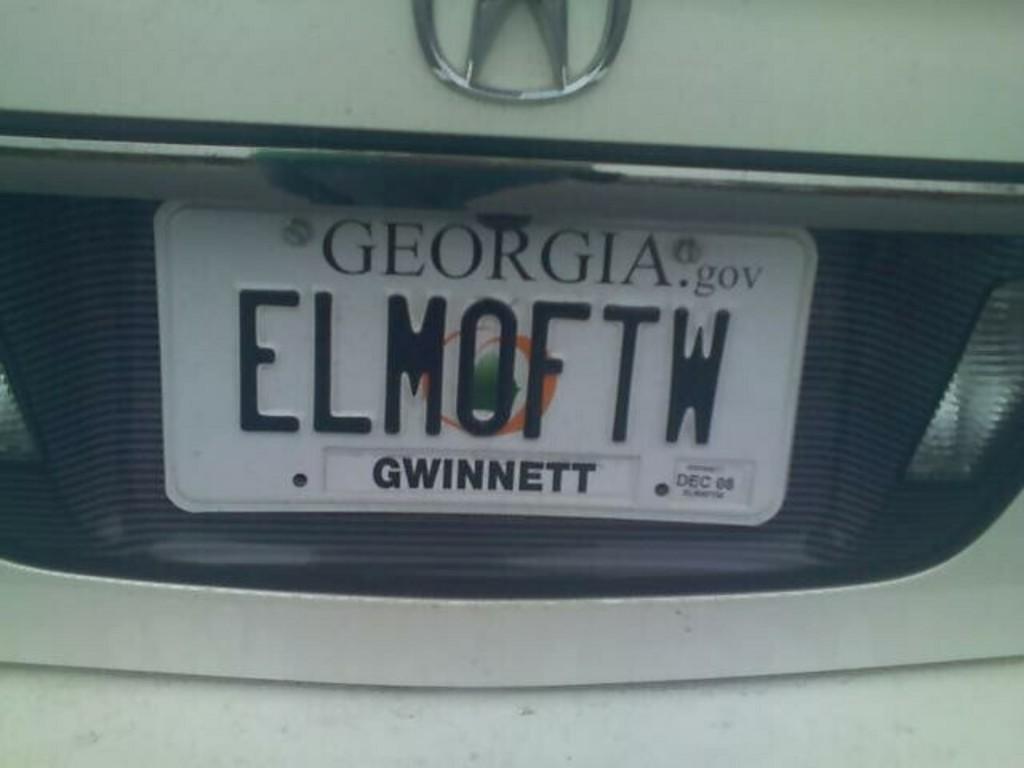What county in georgia is this license plate registered in?
Your response must be concise. Gwinnett. What's the plate read?
Your response must be concise. Elmoftw. 